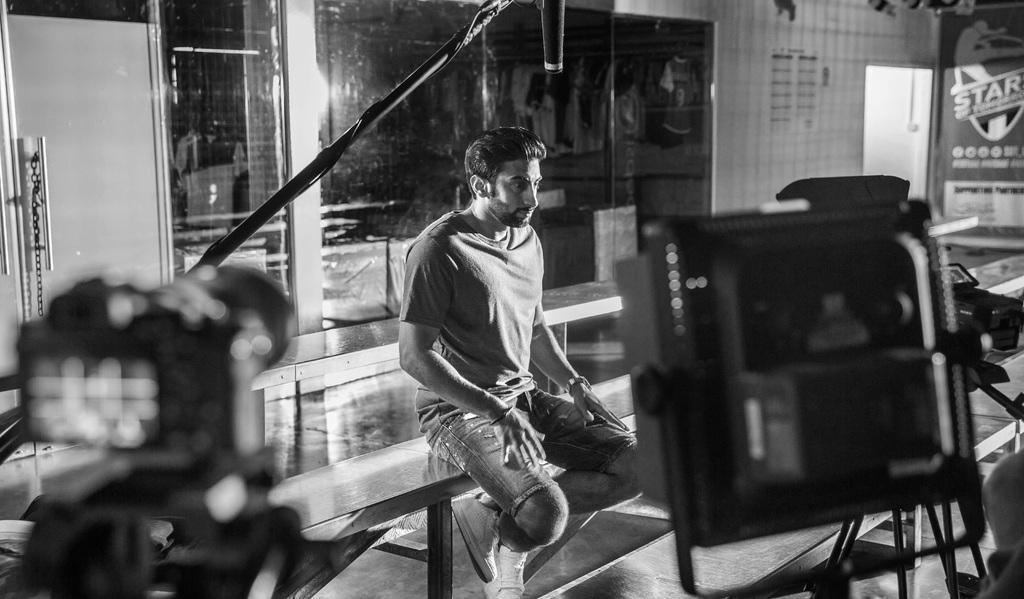How would you summarize this image in a sentence or two? In this image I can see the black and white picture in which I can see a camera, few other equipment, a black colored rod, a person sitting on a bench and the floor. In the background I can see the door, the wall, a microphone and the glass window. 